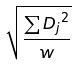Convert formula to latex. <formula><loc_0><loc_0><loc_500><loc_500>\sqrt { \frac { \sum { D _ { j } } ^ { 2 } } { w } }</formula> 